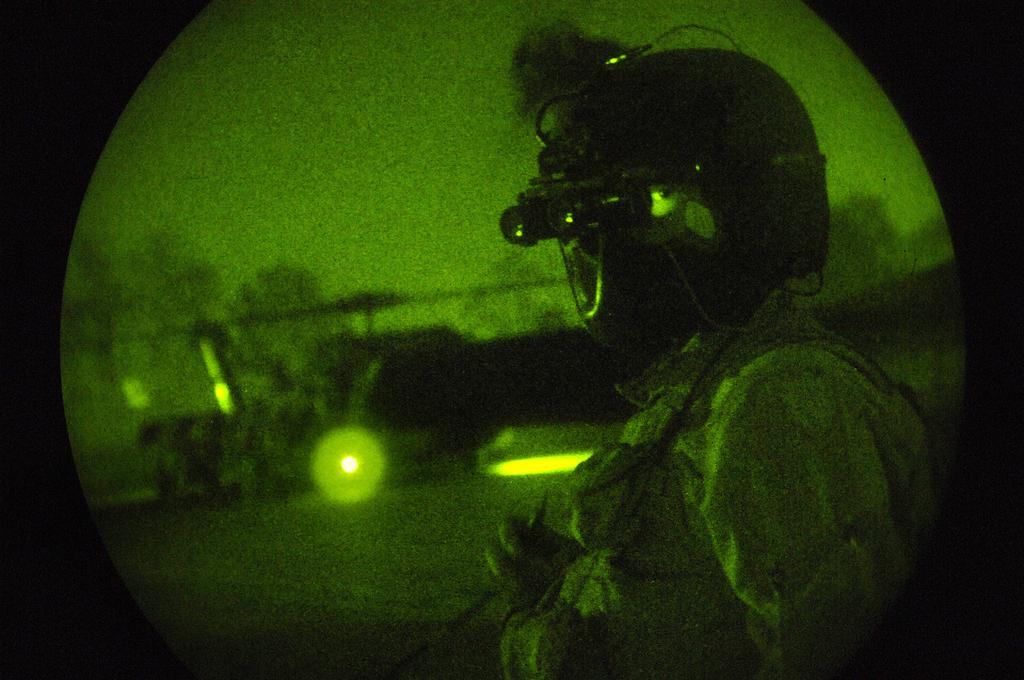What can be seen in the image? There is a person in the image. What is the person wearing? The person is wearing a helmet. Can you describe the background of the image? The background of the image is green and blurry. What type of wall can be seen in the image? There is no wall present in the image; it features a person wearing a helmet with a green and blurry background. 